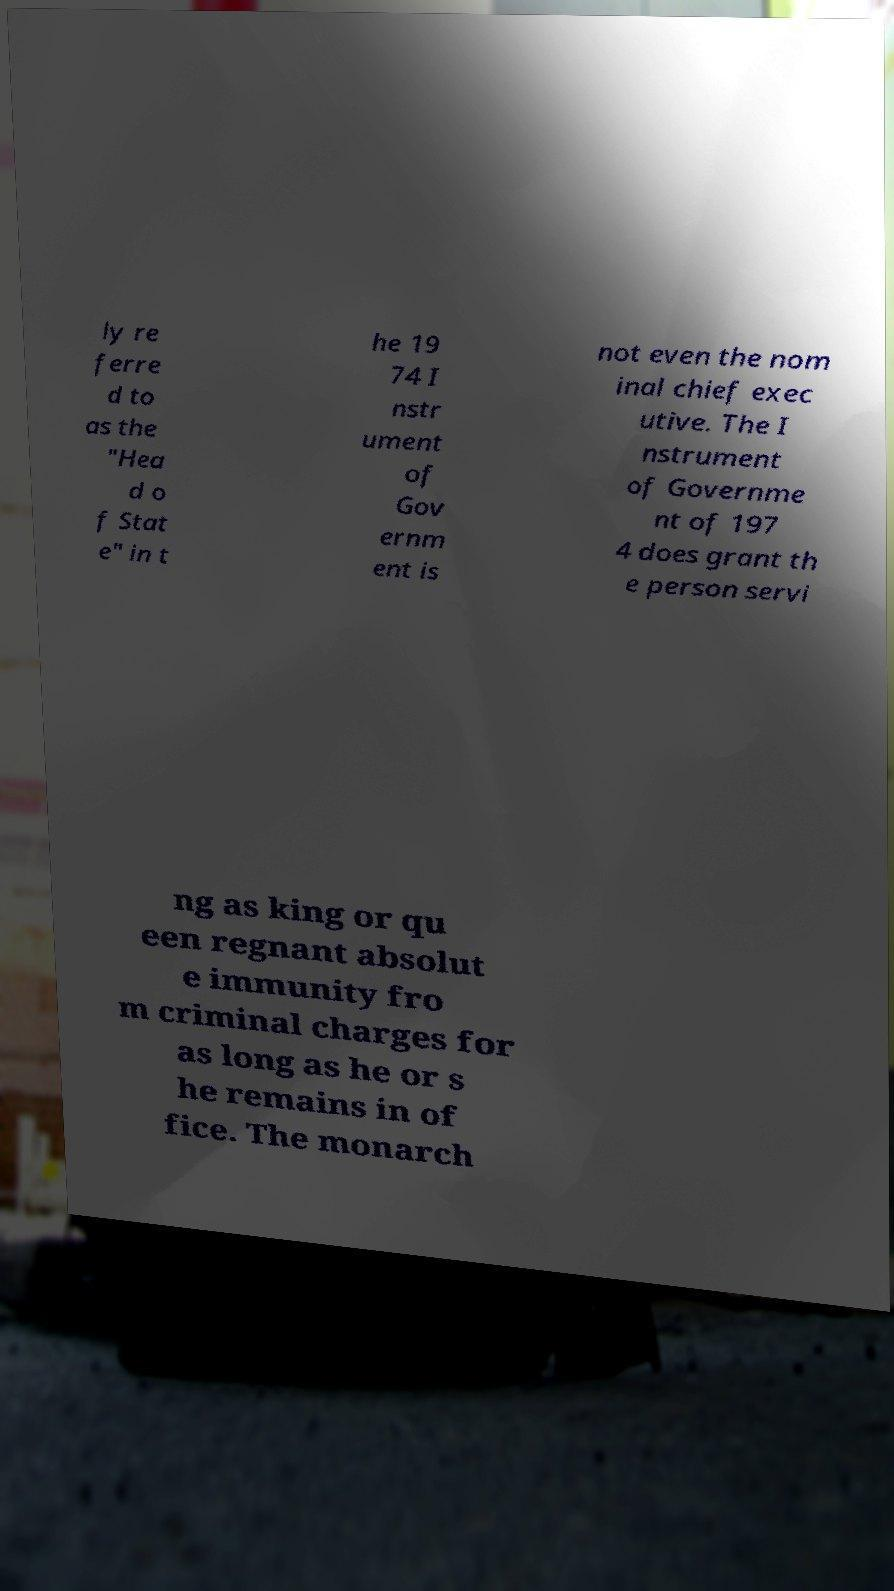Can you accurately transcribe the text from the provided image for me? ly re ferre d to as the "Hea d o f Stat e" in t he 19 74 I nstr ument of Gov ernm ent is not even the nom inal chief exec utive. The I nstrument of Governme nt of 197 4 does grant th e person servi ng as king or qu een regnant absolut e immunity fro m criminal charges for as long as he or s he remains in of fice. The monarch 